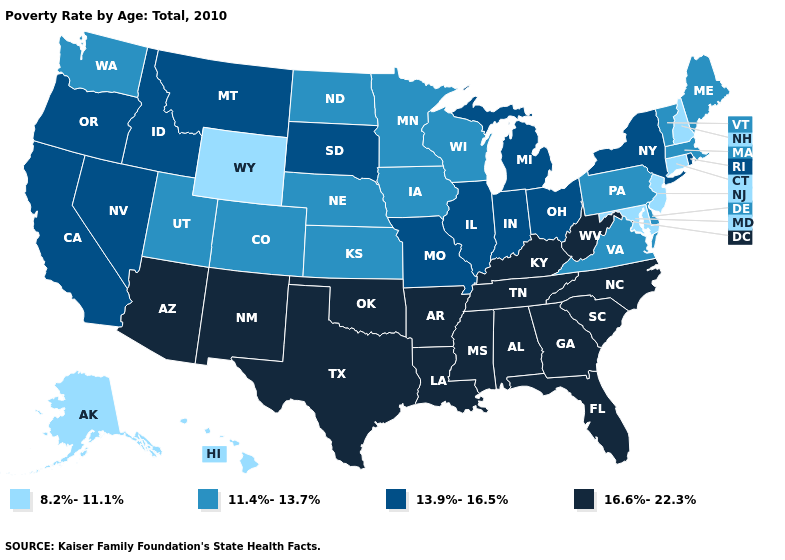What is the highest value in the South ?
Write a very short answer. 16.6%-22.3%. Name the states that have a value in the range 16.6%-22.3%?
Quick response, please. Alabama, Arizona, Arkansas, Florida, Georgia, Kentucky, Louisiana, Mississippi, New Mexico, North Carolina, Oklahoma, South Carolina, Tennessee, Texas, West Virginia. Does Maryland have the highest value in the USA?
Answer briefly. No. Does South Carolina have the highest value in the USA?
Give a very brief answer. Yes. What is the value of Oregon?
Quick response, please. 13.9%-16.5%. What is the highest value in the USA?
Short answer required. 16.6%-22.3%. What is the value of Texas?
Write a very short answer. 16.6%-22.3%. Among the states that border Indiana , which have the highest value?
Give a very brief answer. Kentucky. Is the legend a continuous bar?
Answer briefly. No. What is the value of Maryland?
Give a very brief answer. 8.2%-11.1%. What is the lowest value in the USA?
Concise answer only. 8.2%-11.1%. Among the states that border Delaware , does Pennsylvania have the highest value?
Concise answer only. Yes. What is the highest value in the USA?
Give a very brief answer. 16.6%-22.3%. Name the states that have a value in the range 11.4%-13.7%?
Give a very brief answer. Colorado, Delaware, Iowa, Kansas, Maine, Massachusetts, Minnesota, Nebraska, North Dakota, Pennsylvania, Utah, Vermont, Virginia, Washington, Wisconsin. What is the value of Virginia?
Concise answer only. 11.4%-13.7%. 